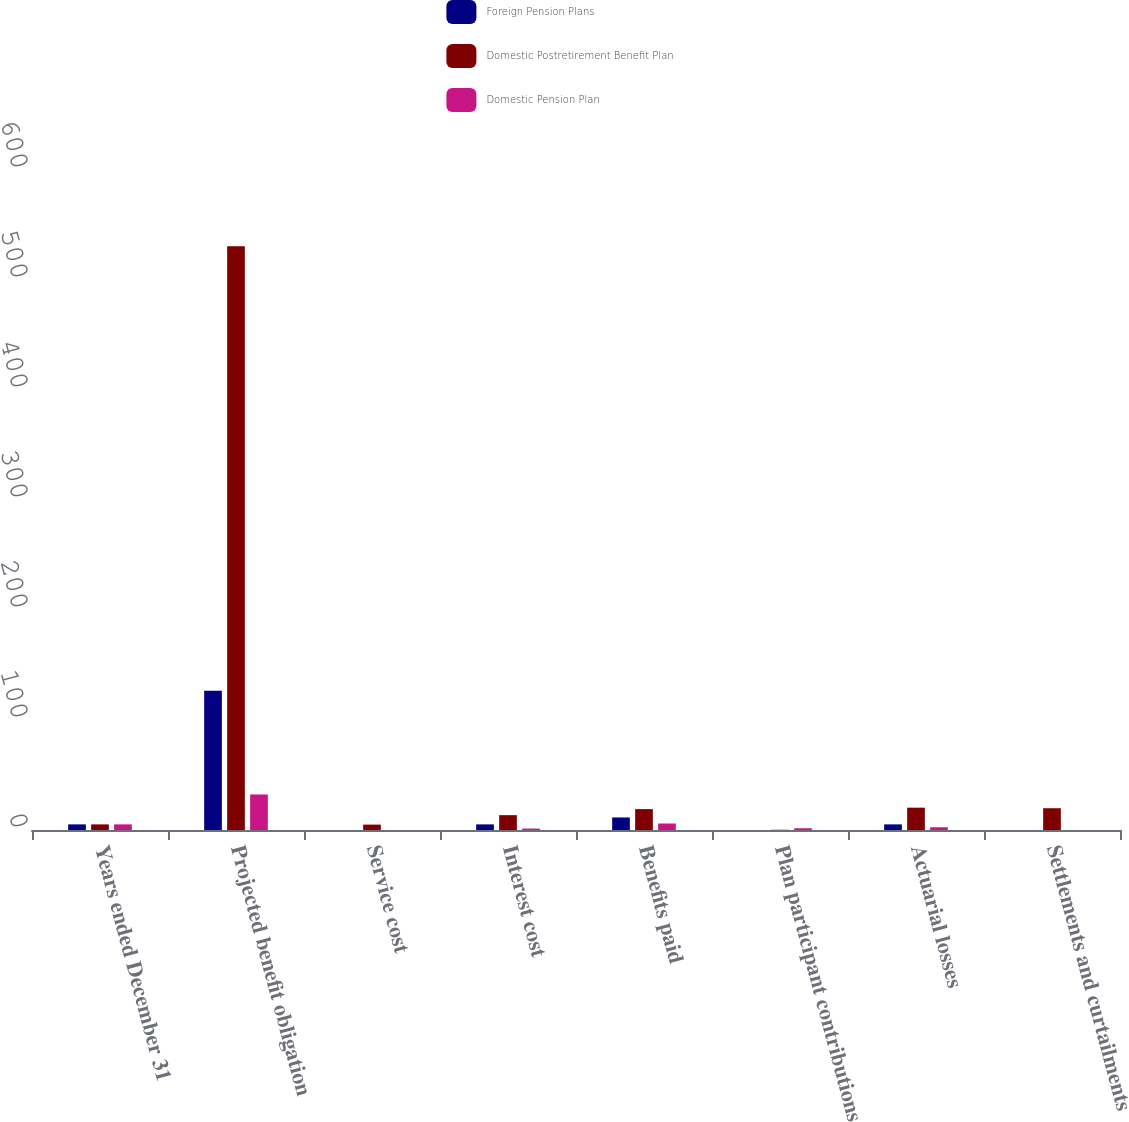Convert chart. <chart><loc_0><loc_0><loc_500><loc_500><stacked_bar_chart><ecel><fcel>Years ended December 31<fcel>Projected benefit obligation<fcel>Service cost<fcel>Interest cost<fcel>Benefits paid<fcel>Plan participant contributions<fcel>Actuarial losses<fcel>Settlements and curtailments<nl><fcel>Foreign Pension Plans<fcel>5.1<fcel>126.6<fcel>0<fcel>5.1<fcel>11.4<fcel>0<fcel>5.1<fcel>0<nl><fcel>Domestic Postretirement Benefit Plan<fcel>5.1<fcel>530.6<fcel>4.9<fcel>13.5<fcel>19<fcel>0.2<fcel>20.3<fcel>19.8<nl><fcel>Domestic Pension Plan<fcel>5.1<fcel>32.3<fcel>0<fcel>1.3<fcel>5.9<fcel>1.6<fcel>2.5<fcel>0<nl></chart> 